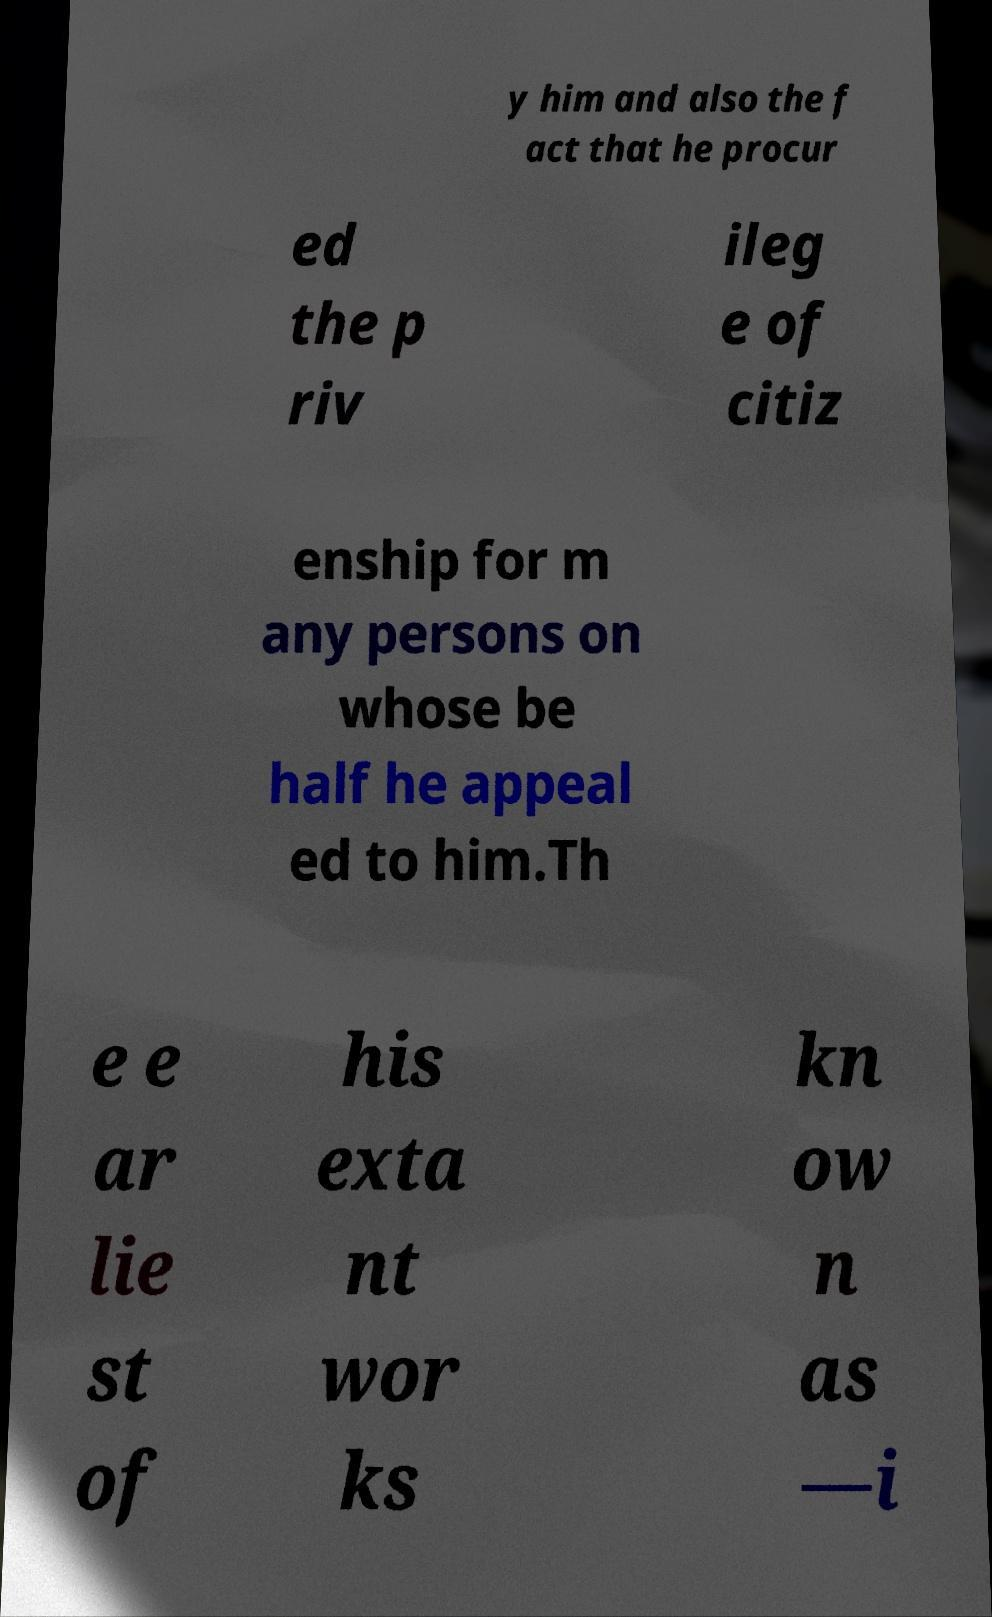Please identify and transcribe the text found in this image. y him and also the f act that he procur ed the p riv ileg e of citiz enship for m any persons on whose be half he appeal ed to him.Th e e ar lie st of his exta nt wor ks kn ow n as —i 